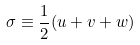Convert formula to latex. <formula><loc_0><loc_0><loc_500><loc_500>\sigma \equiv \frac { 1 } { 2 } ( u + v + w )</formula> 